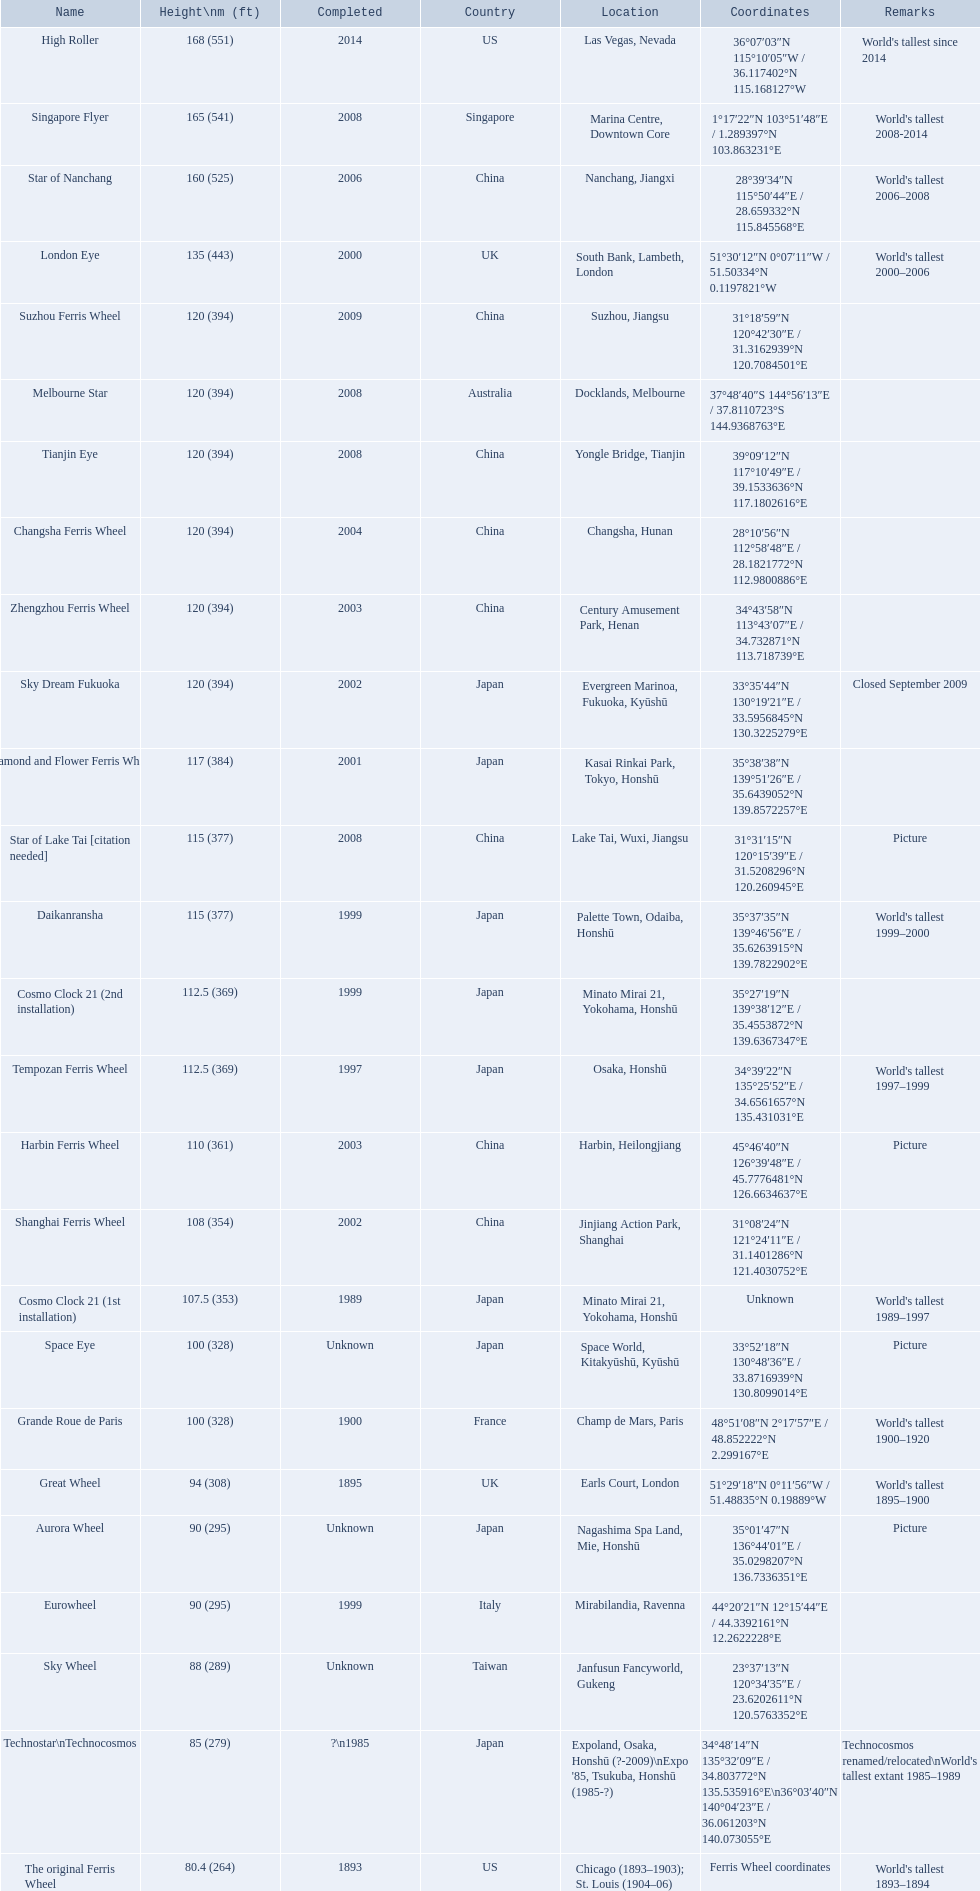When was the completion of the high roller ferris wheel? 2014. Which ferris wheel was finalized in 2006? Star of Nanchang. Which one was done in 2008? Singapore Flyer. What is the star of nanchang roller coaster's height? 165 (541). When was the completion date of the star of nanchang roller coaster? 2008. What is the oldest roller coaster called? Star of Nanchang. 